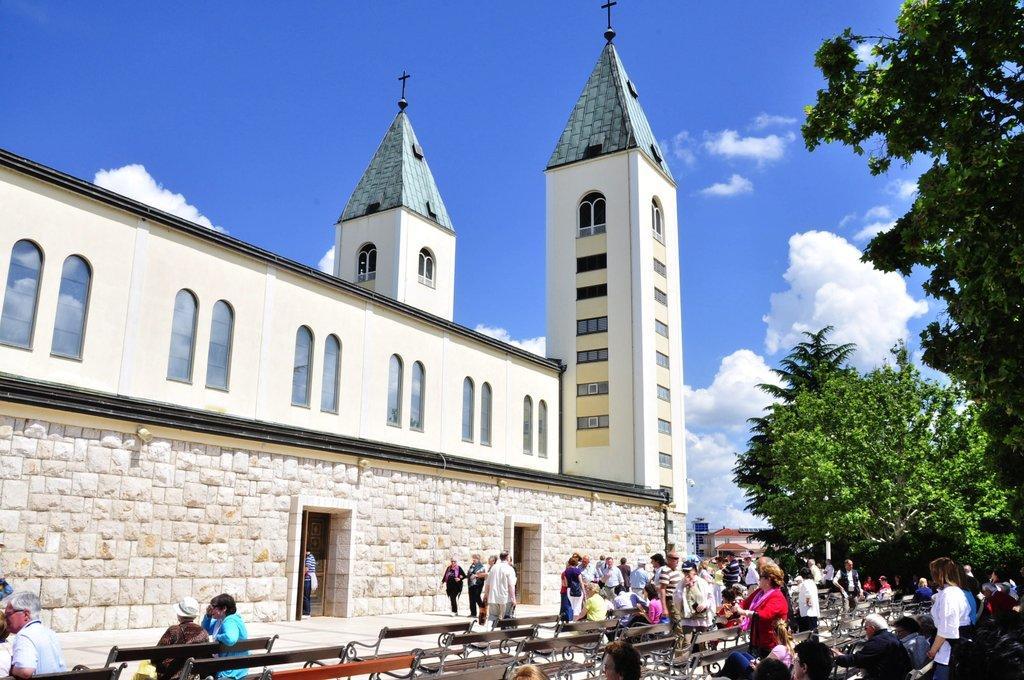Describe this image in one or two sentences. This picture is clicked outside the city. At the bottom of the picture, we see people sitting on the benches and we even see people walking beside the benches. Beside them, we see a church. On the right side of the picture, there are trees. At the top of the picture, we see the sky and the clouds. It is a sunny day. 